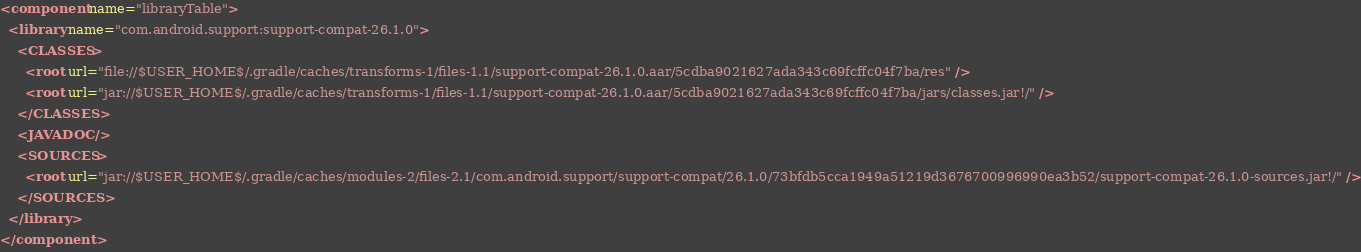Convert code to text. <code><loc_0><loc_0><loc_500><loc_500><_XML_><component name="libraryTable">
  <library name="com.android.support:support-compat-26.1.0">
    <CLASSES>
      <root url="file://$USER_HOME$/.gradle/caches/transforms-1/files-1.1/support-compat-26.1.0.aar/5cdba9021627ada343c69fcffc04f7ba/res" />
      <root url="jar://$USER_HOME$/.gradle/caches/transforms-1/files-1.1/support-compat-26.1.0.aar/5cdba9021627ada343c69fcffc04f7ba/jars/classes.jar!/" />
    </CLASSES>
    <JAVADOC />
    <SOURCES>
      <root url="jar://$USER_HOME$/.gradle/caches/modules-2/files-2.1/com.android.support/support-compat/26.1.0/73bfdb5cca1949a51219d3676700996990ea3b52/support-compat-26.1.0-sources.jar!/" />
    </SOURCES>
  </library>
</component></code> 